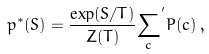Convert formula to latex. <formula><loc_0><loc_0><loc_500><loc_500>p ^ { * } ( S ) = \frac { \exp ( S / T ) } { Z ( T ) } { \sum _ { c } } ^ { ^ { \prime } } P ( c ) \, ,</formula> 